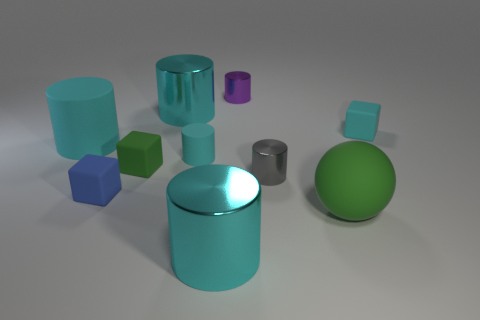Does the green sphere have the same material as the big cyan cylinder that is in front of the tiny blue rubber block?
Provide a succinct answer. No. There is a matte block right of the small cylinder behind the small cyan cylinder; what color is it?
Offer a very short reply. Cyan. What number of balls are either large metal objects or purple metal objects?
Offer a very short reply. 0. How many cyan matte objects are both to the left of the tiny cyan cylinder and right of the large green object?
Provide a short and direct response. 0. What is the color of the rubber block right of the gray metallic object?
Provide a short and direct response. Cyan. There is a sphere that is made of the same material as the small blue cube; what size is it?
Your response must be concise. Large. What number of big cyan matte cylinders are on the left side of the tiny blue object left of the gray object?
Make the answer very short. 1. What number of green rubber objects are to the left of the small gray shiny object?
Your response must be concise. 1. There is a large thing that is right of the small metal cylinder behind the small cyan thing to the right of the small cyan cylinder; what color is it?
Provide a succinct answer. Green. There is a cylinder in front of the tiny blue rubber cube; is it the same color as the rubber object to the right of the green ball?
Offer a terse response. Yes. 